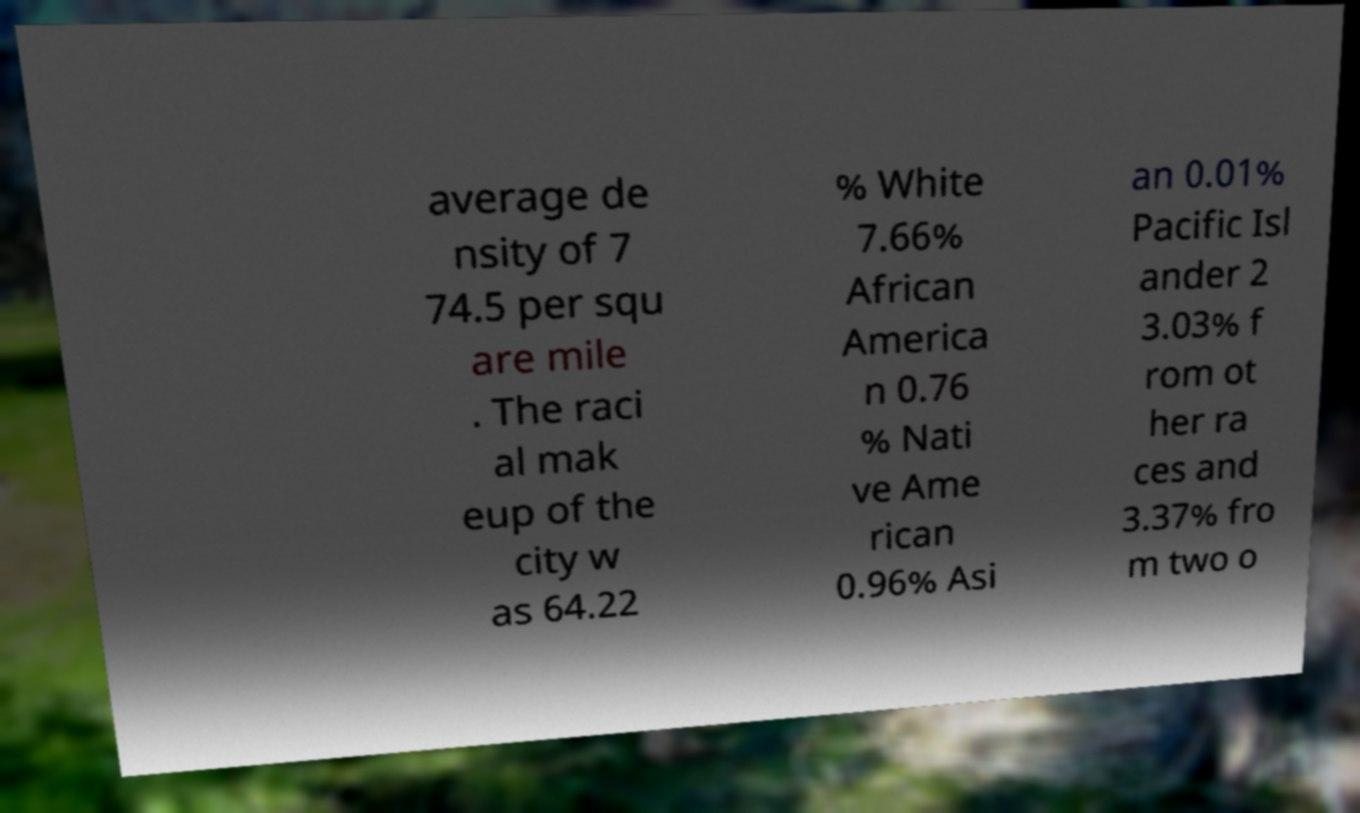For documentation purposes, I need the text within this image transcribed. Could you provide that? average de nsity of 7 74.5 per squ are mile . The raci al mak eup of the city w as 64.22 % White 7.66% African America n 0.76 % Nati ve Ame rican 0.96% Asi an 0.01% Pacific Isl ander 2 3.03% f rom ot her ra ces and 3.37% fro m two o 